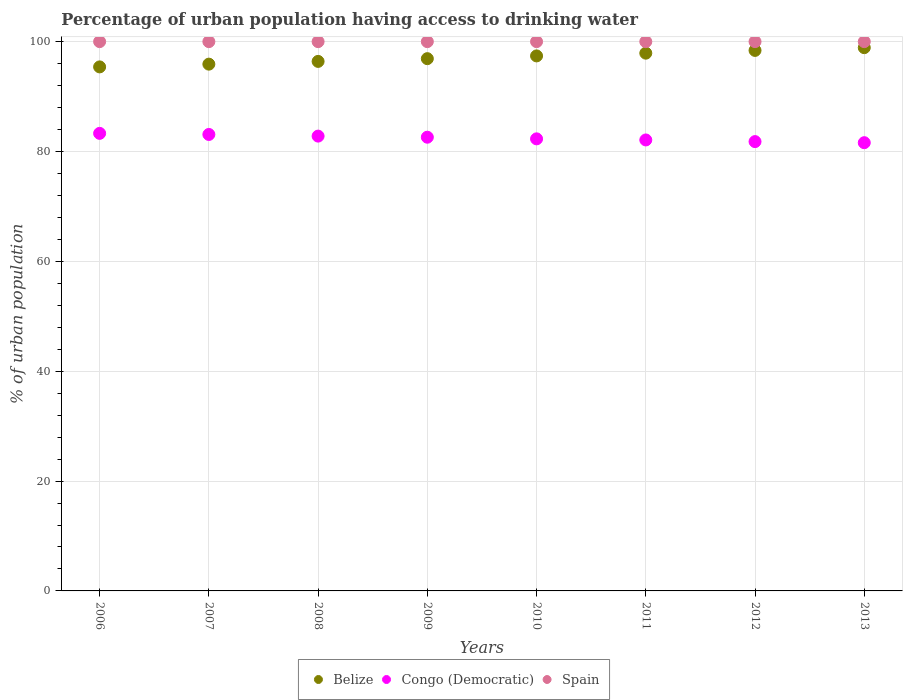Is the number of dotlines equal to the number of legend labels?
Give a very brief answer. Yes. What is the percentage of urban population having access to drinking water in Spain in 2012?
Your answer should be compact. 100. Across all years, what is the minimum percentage of urban population having access to drinking water in Belize?
Make the answer very short. 95.4. In which year was the percentage of urban population having access to drinking water in Spain maximum?
Keep it short and to the point. 2006. In which year was the percentage of urban population having access to drinking water in Congo (Democratic) minimum?
Your answer should be very brief. 2013. What is the total percentage of urban population having access to drinking water in Spain in the graph?
Your answer should be compact. 800. What is the difference between the percentage of urban population having access to drinking water in Belize in 2007 and the percentage of urban population having access to drinking water in Spain in 2012?
Keep it short and to the point. -4.1. What is the average percentage of urban population having access to drinking water in Congo (Democratic) per year?
Ensure brevity in your answer.  82.45. In the year 2011, what is the difference between the percentage of urban population having access to drinking water in Belize and percentage of urban population having access to drinking water in Congo (Democratic)?
Your response must be concise. 15.8. What is the ratio of the percentage of urban population having access to drinking water in Spain in 2007 to that in 2013?
Keep it short and to the point. 1. What is the difference between the highest and the second highest percentage of urban population having access to drinking water in Spain?
Make the answer very short. 0. What is the difference between the highest and the lowest percentage of urban population having access to drinking water in Belize?
Provide a succinct answer. 3.5. Is the sum of the percentage of urban population having access to drinking water in Congo (Democratic) in 2008 and 2013 greater than the maximum percentage of urban population having access to drinking water in Belize across all years?
Make the answer very short. Yes. Is the percentage of urban population having access to drinking water in Spain strictly less than the percentage of urban population having access to drinking water in Congo (Democratic) over the years?
Offer a terse response. No. Are the values on the major ticks of Y-axis written in scientific E-notation?
Make the answer very short. No. Does the graph contain any zero values?
Your response must be concise. No. Where does the legend appear in the graph?
Your response must be concise. Bottom center. How many legend labels are there?
Give a very brief answer. 3. What is the title of the graph?
Give a very brief answer. Percentage of urban population having access to drinking water. What is the label or title of the Y-axis?
Keep it short and to the point. % of urban population. What is the % of urban population in Belize in 2006?
Your response must be concise. 95.4. What is the % of urban population of Congo (Democratic) in 2006?
Make the answer very short. 83.3. What is the % of urban population of Belize in 2007?
Offer a very short reply. 95.9. What is the % of urban population of Congo (Democratic) in 2007?
Make the answer very short. 83.1. What is the % of urban population in Spain in 2007?
Your answer should be compact. 100. What is the % of urban population of Belize in 2008?
Keep it short and to the point. 96.4. What is the % of urban population in Congo (Democratic) in 2008?
Offer a very short reply. 82.8. What is the % of urban population of Belize in 2009?
Make the answer very short. 96.9. What is the % of urban population of Congo (Democratic) in 2009?
Your answer should be compact. 82.6. What is the % of urban population of Belize in 2010?
Provide a short and direct response. 97.4. What is the % of urban population of Congo (Democratic) in 2010?
Offer a very short reply. 82.3. What is the % of urban population of Belize in 2011?
Your response must be concise. 97.9. What is the % of urban population in Congo (Democratic) in 2011?
Provide a short and direct response. 82.1. What is the % of urban population of Spain in 2011?
Make the answer very short. 100. What is the % of urban population of Belize in 2012?
Give a very brief answer. 98.4. What is the % of urban population of Congo (Democratic) in 2012?
Your answer should be compact. 81.8. What is the % of urban population of Belize in 2013?
Make the answer very short. 98.9. What is the % of urban population in Congo (Democratic) in 2013?
Offer a very short reply. 81.6. Across all years, what is the maximum % of urban population of Belize?
Provide a succinct answer. 98.9. Across all years, what is the maximum % of urban population in Congo (Democratic)?
Your answer should be compact. 83.3. Across all years, what is the minimum % of urban population of Belize?
Keep it short and to the point. 95.4. Across all years, what is the minimum % of urban population in Congo (Democratic)?
Provide a short and direct response. 81.6. What is the total % of urban population in Belize in the graph?
Provide a succinct answer. 777.2. What is the total % of urban population of Congo (Democratic) in the graph?
Keep it short and to the point. 659.6. What is the total % of urban population of Spain in the graph?
Ensure brevity in your answer.  800. What is the difference between the % of urban population of Belize in 2006 and that in 2007?
Ensure brevity in your answer.  -0.5. What is the difference between the % of urban population in Congo (Democratic) in 2006 and that in 2009?
Give a very brief answer. 0.7. What is the difference between the % of urban population of Spain in 2006 and that in 2009?
Keep it short and to the point. 0. What is the difference between the % of urban population of Congo (Democratic) in 2006 and that in 2010?
Your answer should be compact. 1. What is the difference between the % of urban population in Belize in 2006 and that in 2011?
Keep it short and to the point. -2.5. What is the difference between the % of urban population in Congo (Democratic) in 2006 and that in 2011?
Make the answer very short. 1.2. What is the difference between the % of urban population in Belize in 2006 and that in 2012?
Offer a very short reply. -3. What is the difference between the % of urban population of Spain in 2006 and that in 2012?
Provide a succinct answer. 0. What is the difference between the % of urban population in Congo (Democratic) in 2006 and that in 2013?
Give a very brief answer. 1.7. What is the difference between the % of urban population in Belize in 2007 and that in 2009?
Offer a terse response. -1. What is the difference between the % of urban population in Congo (Democratic) in 2007 and that in 2009?
Your answer should be compact. 0.5. What is the difference between the % of urban population of Spain in 2007 and that in 2009?
Offer a terse response. 0. What is the difference between the % of urban population in Belize in 2007 and that in 2010?
Give a very brief answer. -1.5. What is the difference between the % of urban population in Belize in 2007 and that in 2011?
Offer a terse response. -2. What is the difference between the % of urban population in Spain in 2007 and that in 2011?
Provide a succinct answer. 0. What is the difference between the % of urban population of Congo (Democratic) in 2007 and that in 2012?
Your response must be concise. 1.3. What is the difference between the % of urban population of Congo (Democratic) in 2007 and that in 2013?
Keep it short and to the point. 1.5. What is the difference between the % of urban population of Belize in 2008 and that in 2009?
Provide a short and direct response. -0.5. What is the difference between the % of urban population of Spain in 2008 and that in 2009?
Make the answer very short. 0. What is the difference between the % of urban population in Congo (Democratic) in 2008 and that in 2010?
Your answer should be compact. 0.5. What is the difference between the % of urban population in Spain in 2008 and that in 2010?
Your answer should be very brief. 0. What is the difference between the % of urban population of Congo (Democratic) in 2008 and that in 2011?
Your response must be concise. 0.7. What is the difference between the % of urban population in Spain in 2008 and that in 2011?
Offer a terse response. 0. What is the difference between the % of urban population in Belize in 2008 and that in 2012?
Ensure brevity in your answer.  -2. What is the difference between the % of urban population in Congo (Democratic) in 2008 and that in 2012?
Your answer should be compact. 1. What is the difference between the % of urban population of Spain in 2008 and that in 2012?
Keep it short and to the point. 0. What is the difference between the % of urban population of Congo (Democratic) in 2009 and that in 2010?
Make the answer very short. 0.3. What is the difference between the % of urban population in Spain in 2009 and that in 2011?
Your response must be concise. 0. What is the difference between the % of urban population of Congo (Democratic) in 2009 and that in 2013?
Ensure brevity in your answer.  1. What is the difference between the % of urban population of Belize in 2010 and that in 2011?
Keep it short and to the point. -0.5. What is the difference between the % of urban population in Congo (Democratic) in 2010 and that in 2011?
Give a very brief answer. 0.2. What is the difference between the % of urban population in Belize in 2010 and that in 2013?
Provide a succinct answer. -1.5. What is the difference between the % of urban population of Congo (Democratic) in 2011 and that in 2012?
Provide a succinct answer. 0.3. What is the difference between the % of urban population of Belize in 2012 and that in 2013?
Your response must be concise. -0.5. What is the difference between the % of urban population in Congo (Democratic) in 2012 and that in 2013?
Your response must be concise. 0.2. What is the difference between the % of urban population of Belize in 2006 and the % of urban population of Congo (Democratic) in 2007?
Your response must be concise. 12.3. What is the difference between the % of urban population in Belize in 2006 and the % of urban population in Spain in 2007?
Keep it short and to the point. -4.6. What is the difference between the % of urban population of Congo (Democratic) in 2006 and the % of urban population of Spain in 2007?
Keep it short and to the point. -16.7. What is the difference between the % of urban population in Congo (Democratic) in 2006 and the % of urban population in Spain in 2008?
Provide a short and direct response. -16.7. What is the difference between the % of urban population of Belize in 2006 and the % of urban population of Congo (Democratic) in 2009?
Keep it short and to the point. 12.8. What is the difference between the % of urban population of Congo (Democratic) in 2006 and the % of urban population of Spain in 2009?
Ensure brevity in your answer.  -16.7. What is the difference between the % of urban population of Belize in 2006 and the % of urban population of Congo (Democratic) in 2010?
Provide a succinct answer. 13.1. What is the difference between the % of urban population of Congo (Democratic) in 2006 and the % of urban population of Spain in 2010?
Offer a terse response. -16.7. What is the difference between the % of urban population of Belize in 2006 and the % of urban population of Congo (Democratic) in 2011?
Provide a short and direct response. 13.3. What is the difference between the % of urban population in Congo (Democratic) in 2006 and the % of urban population in Spain in 2011?
Your answer should be compact. -16.7. What is the difference between the % of urban population of Congo (Democratic) in 2006 and the % of urban population of Spain in 2012?
Offer a terse response. -16.7. What is the difference between the % of urban population in Belize in 2006 and the % of urban population in Congo (Democratic) in 2013?
Your answer should be very brief. 13.8. What is the difference between the % of urban population in Congo (Democratic) in 2006 and the % of urban population in Spain in 2013?
Give a very brief answer. -16.7. What is the difference between the % of urban population of Belize in 2007 and the % of urban population of Congo (Democratic) in 2008?
Provide a short and direct response. 13.1. What is the difference between the % of urban population in Congo (Democratic) in 2007 and the % of urban population in Spain in 2008?
Keep it short and to the point. -16.9. What is the difference between the % of urban population of Belize in 2007 and the % of urban population of Congo (Democratic) in 2009?
Your answer should be very brief. 13.3. What is the difference between the % of urban population of Belize in 2007 and the % of urban population of Spain in 2009?
Offer a very short reply. -4.1. What is the difference between the % of urban population in Congo (Democratic) in 2007 and the % of urban population in Spain in 2009?
Keep it short and to the point. -16.9. What is the difference between the % of urban population in Belize in 2007 and the % of urban population in Congo (Democratic) in 2010?
Your response must be concise. 13.6. What is the difference between the % of urban population of Belize in 2007 and the % of urban population of Spain in 2010?
Offer a very short reply. -4.1. What is the difference between the % of urban population in Congo (Democratic) in 2007 and the % of urban population in Spain in 2010?
Give a very brief answer. -16.9. What is the difference between the % of urban population in Belize in 2007 and the % of urban population in Congo (Democratic) in 2011?
Your answer should be very brief. 13.8. What is the difference between the % of urban population of Belize in 2007 and the % of urban population of Spain in 2011?
Your answer should be very brief. -4.1. What is the difference between the % of urban population of Congo (Democratic) in 2007 and the % of urban population of Spain in 2011?
Give a very brief answer. -16.9. What is the difference between the % of urban population in Congo (Democratic) in 2007 and the % of urban population in Spain in 2012?
Provide a succinct answer. -16.9. What is the difference between the % of urban population in Belize in 2007 and the % of urban population in Congo (Democratic) in 2013?
Your answer should be very brief. 14.3. What is the difference between the % of urban population of Congo (Democratic) in 2007 and the % of urban population of Spain in 2013?
Make the answer very short. -16.9. What is the difference between the % of urban population of Belize in 2008 and the % of urban population of Congo (Democratic) in 2009?
Keep it short and to the point. 13.8. What is the difference between the % of urban population in Congo (Democratic) in 2008 and the % of urban population in Spain in 2009?
Make the answer very short. -17.2. What is the difference between the % of urban population of Belize in 2008 and the % of urban population of Spain in 2010?
Your answer should be very brief. -3.6. What is the difference between the % of urban population of Congo (Democratic) in 2008 and the % of urban population of Spain in 2010?
Give a very brief answer. -17.2. What is the difference between the % of urban population of Congo (Democratic) in 2008 and the % of urban population of Spain in 2011?
Your answer should be compact. -17.2. What is the difference between the % of urban population in Congo (Democratic) in 2008 and the % of urban population in Spain in 2012?
Offer a very short reply. -17.2. What is the difference between the % of urban population of Belize in 2008 and the % of urban population of Congo (Democratic) in 2013?
Offer a terse response. 14.8. What is the difference between the % of urban population in Congo (Democratic) in 2008 and the % of urban population in Spain in 2013?
Ensure brevity in your answer.  -17.2. What is the difference between the % of urban population of Belize in 2009 and the % of urban population of Spain in 2010?
Give a very brief answer. -3.1. What is the difference between the % of urban population of Congo (Democratic) in 2009 and the % of urban population of Spain in 2010?
Provide a short and direct response. -17.4. What is the difference between the % of urban population of Belize in 2009 and the % of urban population of Spain in 2011?
Keep it short and to the point. -3.1. What is the difference between the % of urban population of Congo (Democratic) in 2009 and the % of urban population of Spain in 2011?
Your answer should be compact. -17.4. What is the difference between the % of urban population in Belize in 2009 and the % of urban population in Spain in 2012?
Your answer should be compact. -3.1. What is the difference between the % of urban population in Congo (Democratic) in 2009 and the % of urban population in Spain in 2012?
Your response must be concise. -17.4. What is the difference between the % of urban population in Belize in 2009 and the % of urban population in Spain in 2013?
Make the answer very short. -3.1. What is the difference between the % of urban population in Congo (Democratic) in 2009 and the % of urban population in Spain in 2013?
Your response must be concise. -17.4. What is the difference between the % of urban population in Belize in 2010 and the % of urban population in Congo (Democratic) in 2011?
Provide a short and direct response. 15.3. What is the difference between the % of urban population in Belize in 2010 and the % of urban population in Spain in 2011?
Keep it short and to the point. -2.6. What is the difference between the % of urban population of Congo (Democratic) in 2010 and the % of urban population of Spain in 2011?
Offer a very short reply. -17.7. What is the difference between the % of urban population of Belize in 2010 and the % of urban population of Congo (Democratic) in 2012?
Your answer should be very brief. 15.6. What is the difference between the % of urban population of Belize in 2010 and the % of urban population of Spain in 2012?
Your answer should be compact. -2.6. What is the difference between the % of urban population of Congo (Democratic) in 2010 and the % of urban population of Spain in 2012?
Your response must be concise. -17.7. What is the difference between the % of urban population in Belize in 2010 and the % of urban population in Congo (Democratic) in 2013?
Give a very brief answer. 15.8. What is the difference between the % of urban population of Belize in 2010 and the % of urban population of Spain in 2013?
Give a very brief answer. -2.6. What is the difference between the % of urban population in Congo (Democratic) in 2010 and the % of urban population in Spain in 2013?
Your answer should be very brief. -17.7. What is the difference between the % of urban population of Belize in 2011 and the % of urban population of Spain in 2012?
Provide a short and direct response. -2.1. What is the difference between the % of urban population of Congo (Democratic) in 2011 and the % of urban population of Spain in 2012?
Offer a very short reply. -17.9. What is the difference between the % of urban population in Congo (Democratic) in 2011 and the % of urban population in Spain in 2013?
Provide a succinct answer. -17.9. What is the difference between the % of urban population of Congo (Democratic) in 2012 and the % of urban population of Spain in 2013?
Provide a succinct answer. -18.2. What is the average % of urban population of Belize per year?
Give a very brief answer. 97.15. What is the average % of urban population in Congo (Democratic) per year?
Provide a succinct answer. 82.45. What is the average % of urban population of Spain per year?
Ensure brevity in your answer.  100. In the year 2006, what is the difference between the % of urban population in Belize and % of urban population in Spain?
Your answer should be compact. -4.6. In the year 2006, what is the difference between the % of urban population of Congo (Democratic) and % of urban population of Spain?
Offer a very short reply. -16.7. In the year 2007, what is the difference between the % of urban population of Belize and % of urban population of Congo (Democratic)?
Provide a short and direct response. 12.8. In the year 2007, what is the difference between the % of urban population of Belize and % of urban population of Spain?
Offer a very short reply. -4.1. In the year 2007, what is the difference between the % of urban population of Congo (Democratic) and % of urban population of Spain?
Give a very brief answer. -16.9. In the year 2008, what is the difference between the % of urban population in Belize and % of urban population in Spain?
Ensure brevity in your answer.  -3.6. In the year 2008, what is the difference between the % of urban population of Congo (Democratic) and % of urban population of Spain?
Offer a terse response. -17.2. In the year 2009, what is the difference between the % of urban population in Congo (Democratic) and % of urban population in Spain?
Provide a succinct answer. -17.4. In the year 2010, what is the difference between the % of urban population in Congo (Democratic) and % of urban population in Spain?
Provide a succinct answer. -17.7. In the year 2011, what is the difference between the % of urban population in Belize and % of urban population in Spain?
Provide a short and direct response. -2.1. In the year 2011, what is the difference between the % of urban population in Congo (Democratic) and % of urban population in Spain?
Your response must be concise. -17.9. In the year 2012, what is the difference between the % of urban population of Belize and % of urban population of Congo (Democratic)?
Provide a short and direct response. 16.6. In the year 2012, what is the difference between the % of urban population in Congo (Democratic) and % of urban population in Spain?
Provide a succinct answer. -18.2. In the year 2013, what is the difference between the % of urban population in Congo (Democratic) and % of urban population in Spain?
Provide a short and direct response. -18.4. What is the ratio of the % of urban population of Spain in 2006 to that in 2007?
Provide a short and direct response. 1. What is the ratio of the % of urban population in Belize in 2006 to that in 2008?
Ensure brevity in your answer.  0.99. What is the ratio of the % of urban population of Spain in 2006 to that in 2008?
Your answer should be compact. 1. What is the ratio of the % of urban population of Belize in 2006 to that in 2009?
Provide a succinct answer. 0.98. What is the ratio of the % of urban population of Congo (Democratic) in 2006 to that in 2009?
Offer a terse response. 1.01. What is the ratio of the % of urban population in Belize in 2006 to that in 2010?
Provide a succinct answer. 0.98. What is the ratio of the % of urban population in Congo (Democratic) in 2006 to that in 2010?
Your answer should be compact. 1.01. What is the ratio of the % of urban population in Belize in 2006 to that in 2011?
Your answer should be very brief. 0.97. What is the ratio of the % of urban population in Congo (Democratic) in 2006 to that in 2011?
Keep it short and to the point. 1.01. What is the ratio of the % of urban population in Belize in 2006 to that in 2012?
Your answer should be compact. 0.97. What is the ratio of the % of urban population of Congo (Democratic) in 2006 to that in 2012?
Offer a very short reply. 1.02. What is the ratio of the % of urban population in Spain in 2006 to that in 2012?
Offer a very short reply. 1. What is the ratio of the % of urban population in Belize in 2006 to that in 2013?
Provide a succinct answer. 0.96. What is the ratio of the % of urban population in Congo (Democratic) in 2006 to that in 2013?
Provide a short and direct response. 1.02. What is the ratio of the % of urban population of Congo (Democratic) in 2007 to that in 2008?
Give a very brief answer. 1. What is the ratio of the % of urban population of Spain in 2007 to that in 2008?
Ensure brevity in your answer.  1. What is the ratio of the % of urban population in Belize in 2007 to that in 2009?
Offer a very short reply. 0.99. What is the ratio of the % of urban population in Spain in 2007 to that in 2009?
Your response must be concise. 1. What is the ratio of the % of urban population in Belize in 2007 to that in 2010?
Keep it short and to the point. 0.98. What is the ratio of the % of urban population of Congo (Democratic) in 2007 to that in 2010?
Your response must be concise. 1.01. What is the ratio of the % of urban population in Spain in 2007 to that in 2010?
Offer a very short reply. 1. What is the ratio of the % of urban population in Belize in 2007 to that in 2011?
Provide a short and direct response. 0.98. What is the ratio of the % of urban population in Congo (Democratic) in 2007 to that in 2011?
Ensure brevity in your answer.  1.01. What is the ratio of the % of urban population of Belize in 2007 to that in 2012?
Keep it short and to the point. 0.97. What is the ratio of the % of urban population of Congo (Democratic) in 2007 to that in 2012?
Your answer should be very brief. 1.02. What is the ratio of the % of urban population of Belize in 2007 to that in 2013?
Give a very brief answer. 0.97. What is the ratio of the % of urban population of Congo (Democratic) in 2007 to that in 2013?
Offer a terse response. 1.02. What is the ratio of the % of urban population in Belize in 2008 to that in 2009?
Provide a succinct answer. 0.99. What is the ratio of the % of urban population of Congo (Democratic) in 2008 to that in 2009?
Ensure brevity in your answer.  1. What is the ratio of the % of urban population of Belize in 2008 to that in 2010?
Your response must be concise. 0.99. What is the ratio of the % of urban population in Spain in 2008 to that in 2010?
Give a very brief answer. 1. What is the ratio of the % of urban population of Belize in 2008 to that in 2011?
Your answer should be compact. 0.98. What is the ratio of the % of urban population of Congo (Democratic) in 2008 to that in 2011?
Keep it short and to the point. 1.01. What is the ratio of the % of urban population in Spain in 2008 to that in 2011?
Offer a terse response. 1. What is the ratio of the % of urban population in Belize in 2008 to that in 2012?
Give a very brief answer. 0.98. What is the ratio of the % of urban population of Congo (Democratic) in 2008 to that in 2012?
Provide a succinct answer. 1.01. What is the ratio of the % of urban population in Belize in 2008 to that in 2013?
Provide a short and direct response. 0.97. What is the ratio of the % of urban population in Congo (Democratic) in 2008 to that in 2013?
Offer a very short reply. 1.01. What is the ratio of the % of urban population in Congo (Democratic) in 2009 to that in 2010?
Offer a terse response. 1. What is the ratio of the % of urban population of Congo (Democratic) in 2009 to that in 2011?
Keep it short and to the point. 1.01. What is the ratio of the % of urban population in Congo (Democratic) in 2009 to that in 2012?
Offer a very short reply. 1.01. What is the ratio of the % of urban population in Spain in 2009 to that in 2012?
Provide a short and direct response. 1. What is the ratio of the % of urban population in Belize in 2009 to that in 2013?
Your response must be concise. 0.98. What is the ratio of the % of urban population of Congo (Democratic) in 2009 to that in 2013?
Offer a terse response. 1.01. What is the ratio of the % of urban population of Spain in 2009 to that in 2013?
Your response must be concise. 1. What is the ratio of the % of urban population of Congo (Democratic) in 2010 to that in 2011?
Give a very brief answer. 1. What is the ratio of the % of urban population in Spain in 2010 to that in 2011?
Keep it short and to the point. 1. What is the ratio of the % of urban population in Congo (Democratic) in 2010 to that in 2012?
Provide a succinct answer. 1.01. What is the ratio of the % of urban population in Spain in 2010 to that in 2012?
Make the answer very short. 1. What is the ratio of the % of urban population in Belize in 2010 to that in 2013?
Your response must be concise. 0.98. What is the ratio of the % of urban population in Congo (Democratic) in 2010 to that in 2013?
Keep it short and to the point. 1.01. What is the ratio of the % of urban population of Spain in 2010 to that in 2013?
Give a very brief answer. 1. What is the ratio of the % of urban population in Belize in 2011 to that in 2013?
Offer a terse response. 0.99. What is the ratio of the % of urban population in Belize in 2012 to that in 2013?
Provide a succinct answer. 0.99. What is the ratio of the % of urban population in Spain in 2012 to that in 2013?
Give a very brief answer. 1. What is the difference between the highest and the second highest % of urban population of Belize?
Your answer should be very brief. 0.5. What is the difference between the highest and the second highest % of urban population of Congo (Democratic)?
Provide a succinct answer. 0.2. What is the difference between the highest and the second highest % of urban population of Spain?
Ensure brevity in your answer.  0. What is the difference between the highest and the lowest % of urban population of Belize?
Offer a terse response. 3.5. What is the difference between the highest and the lowest % of urban population in Congo (Democratic)?
Your response must be concise. 1.7. 